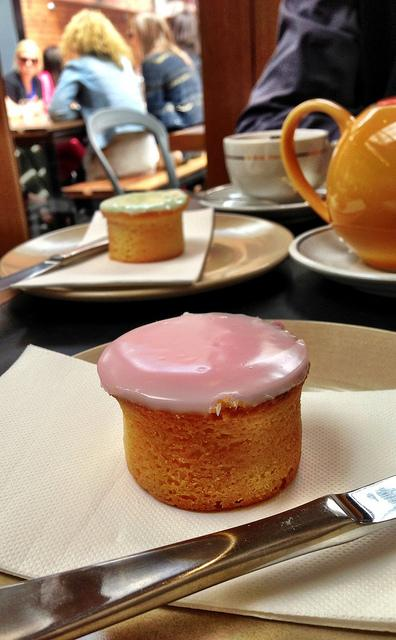What kitchen cooker is necessary for this treat's preparation? oven 